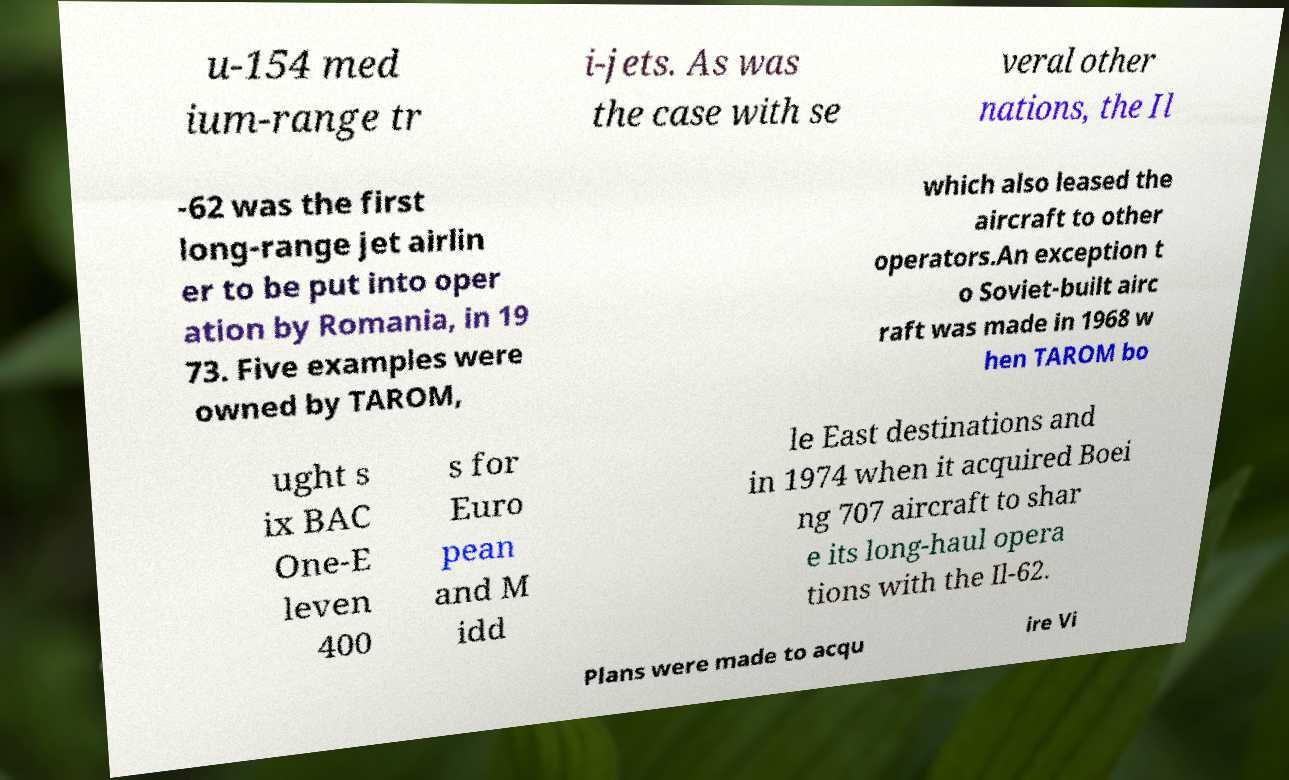I need the written content from this picture converted into text. Can you do that? u-154 med ium-range tr i-jets. As was the case with se veral other nations, the Il -62 was the first long-range jet airlin er to be put into oper ation by Romania, in 19 73. Five examples were owned by TAROM, which also leased the aircraft to other operators.An exception t o Soviet-built airc raft was made in 1968 w hen TAROM bo ught s ix BAC One-E leven 400 s for Euro pean and M idd le East destinations and in 1974 when it acquired Boei ng 707 aircraft to shar e its long-haul opera tions with the Il-62. Plans were made to acqu ire Vi 